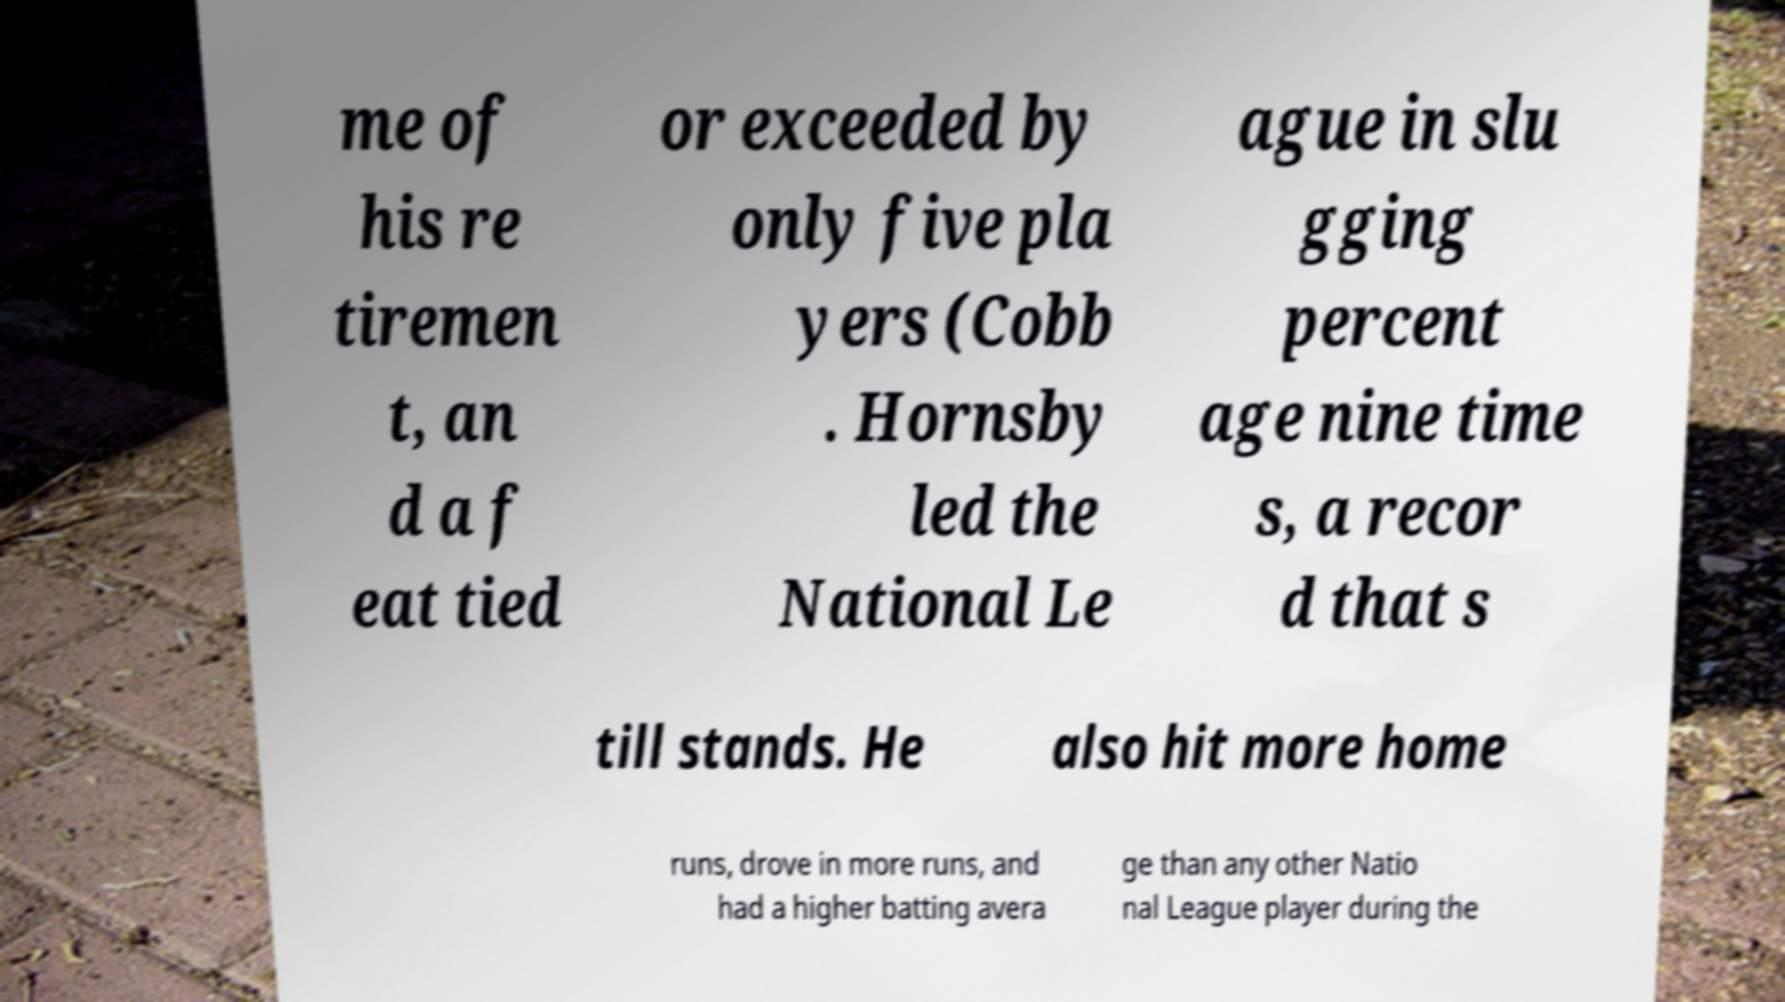For documentation purposes, I need the text within this image transcribed. Could you provide that? me of his re tiremen t, an d a f eat tied or exceeded by only five pla yers (Cobb . Hornsby led the National Le ague in slu gging percent age nine time s, a recor d that s till stands. He also hit more home runs, drove in more runs, and had a higher batting avera ge than any other Natio nal League player during the 